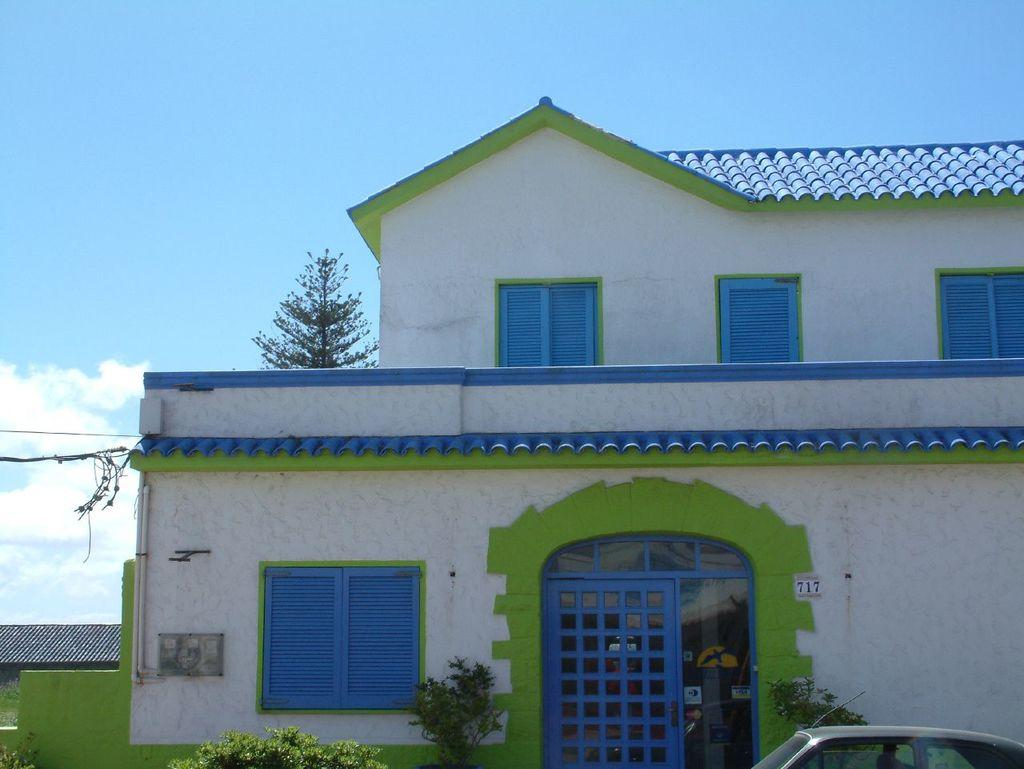What type of structure is visible in the image? There is a house in the image. What colors are present on the house? The house has blue, white, and green colors. What is parked in front of the house? There is a car in front of the house. What type of vegetation is present near the house? There are plants in front of the house wall. What type of furniture is visible inside the house in the image? There is no furniture visible inside the house in the image; only the exterior of the house is shown. 